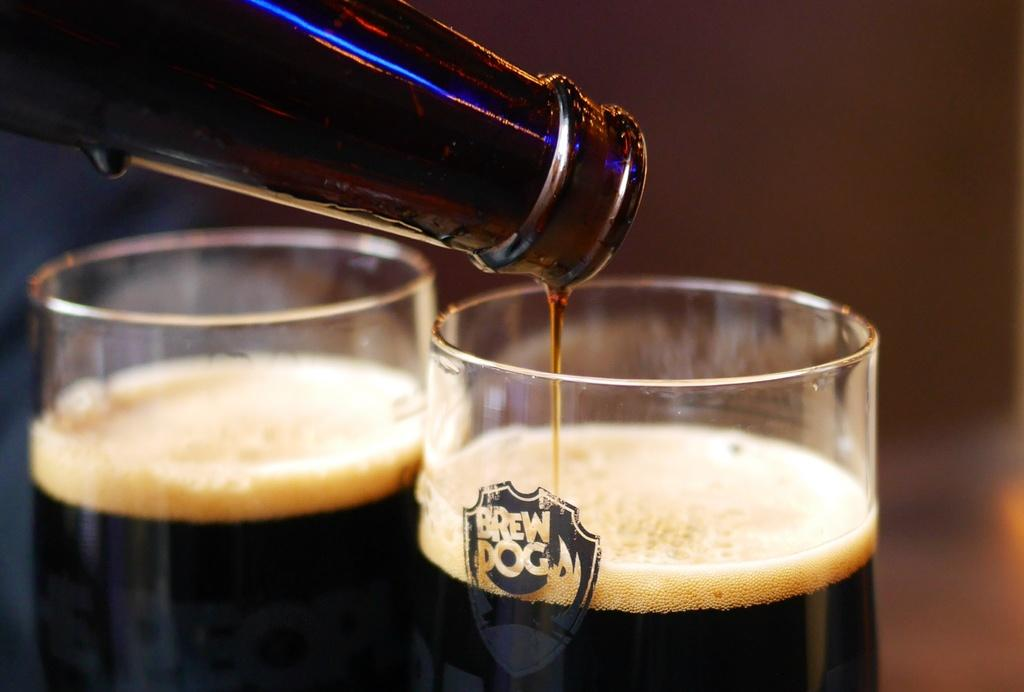<image>
Share a concise interpretation of the image provided. A few glasses are shown with liquor in them, one says BREW DOG on it. 